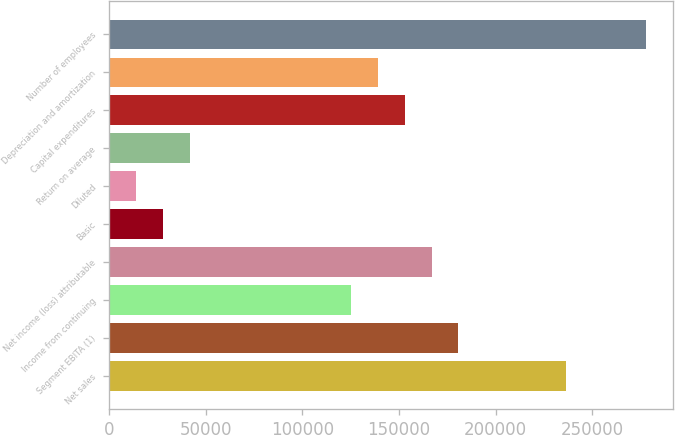Convert chart. <chart><loc_0><loc_0><loc_500><loc_500><bar_chart><fcel>Net sales<fcel>Segment EBITA (1)<fcel>Income from continuing<fcel>Net income (loss) attributable<fcel>Basic<fcel>Diluted<fcel>Return on average<fcel>Capital expenditures<fcel>Depreciation and amortization<fcel>Number of employees<nl><fcel>236299<fcel>180700<fcel>125100<fcel>166800<fcel>27800.8<fcel>13900.9<fcel>41700.7<fcel>152900<fcel>139000<fcel>277999<nl></chart> 